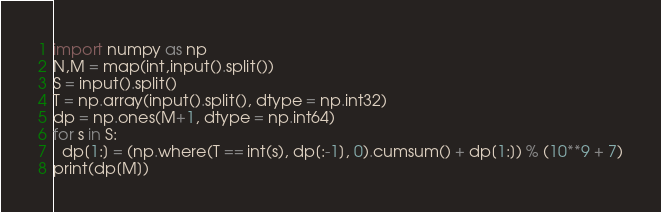Convert code to text. <code><loc_0><loc_0><loc_500><loc_500><_Python_>import numpy as np
N,M = map(int,input().split())
S = input().split()
T = np.array(input().split(), dtype = np.int32)
dp = np.ones(M+1, dtype = np.int64)
for s in S:
  dp[1:] = (np.where(T == int(s), dp[:-1], 0).cumsum() + dp[1:]) % (10**9 + 7)
print(dp[M])</code> 